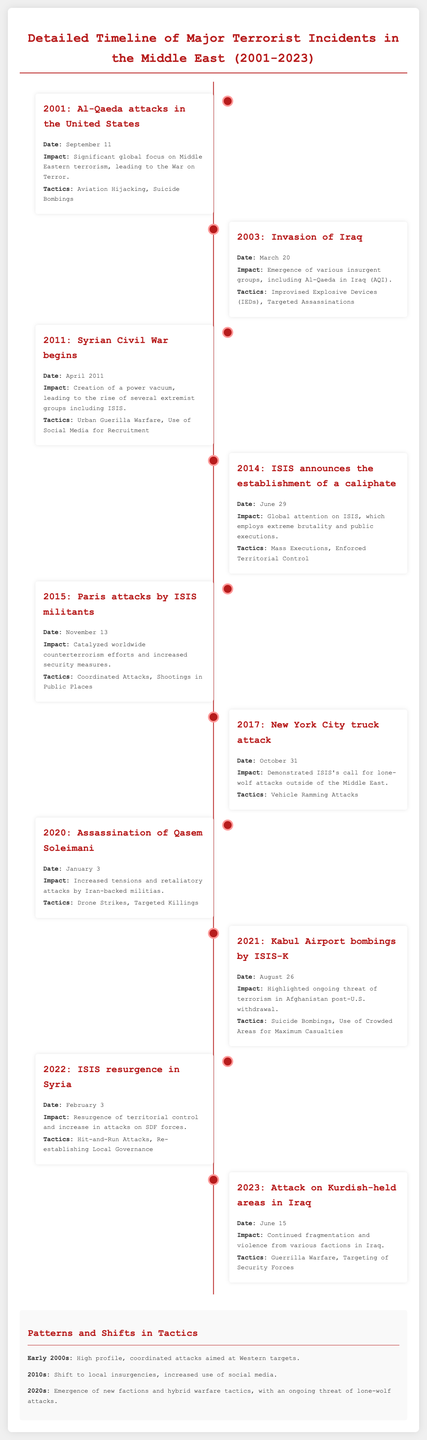what year did the Al-Qaeda attacks in the United States occur? The document states that the Al-Qaeda attacks happened on September 11, 2001.
Answer: 2001 what significant event started on April 2011? The document mentions the Syrian Civil War beginning in April 2011, leading to the rise of extremist groups.
Answer: Syrian Civil War which extremist group announced the establishment of a caliphate in 2014? According to the document, ISIS announced the establishment of a caliphate on June 29, 2014.
Answer: ISIS what tactic was notably used in the 2015 Paris attacks? The document indicates that the 2015 Paris attacks involved coordinated attacks and shootings in public places.
Answer: Coordinated Attacks what was a key shift in tactics described for the 2020s? The document outlines that the 2020s saw the emergence of new factions and hybrid warfare tactics, along with ongoing lone-wolf attack threats.
Answer: New factions and hybrid warfare tactics which year saw the assassination of Qasem Soleimani? The document states that Qasem Soleimani was assassinated on January 3, 2020.
Answer: 2020 what is a common tactic used by ISIS-K during the Kabul Airport bombings? The document mentions that ISIS-K employed suicide bombings during the Kabul Airport bombings on August 26, 2021.
Answer: Suicide Bombings what type of warfare was seen in the 2023 attack on Kurdish-held areas? The document indicates that guerrilla warfare was a tactic used in the 2023 attack on Kurdish-held areas in Iraq.
Answer: Guerrilla Warfare what impact did the 2001 Al-Qaeda attacks have on global terrorism focus? The document states it led to significant global focus on Middle Eastern terrorism and the War on Terror.
Answer: War on Terror 